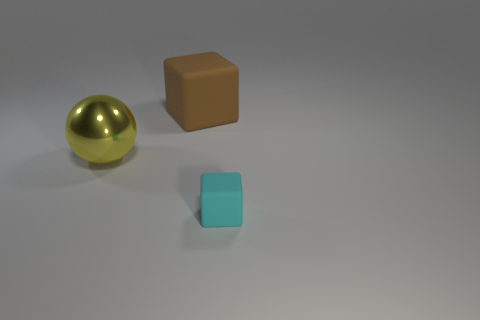Add 3 cyan cubes. How many objects exist? 6 Subtract all blocks. How many objects are left? 1 Subtract 1 yellow spheres. How many objects are left? 2 Subtract all large brown rubber blocks. Subtract all brown metal cylinders. How many objects are left? 2 Add 2 small cyan things. How many small cyan things are left? 3 Add 1 rubber objects. How many rubber objects exist? 3 